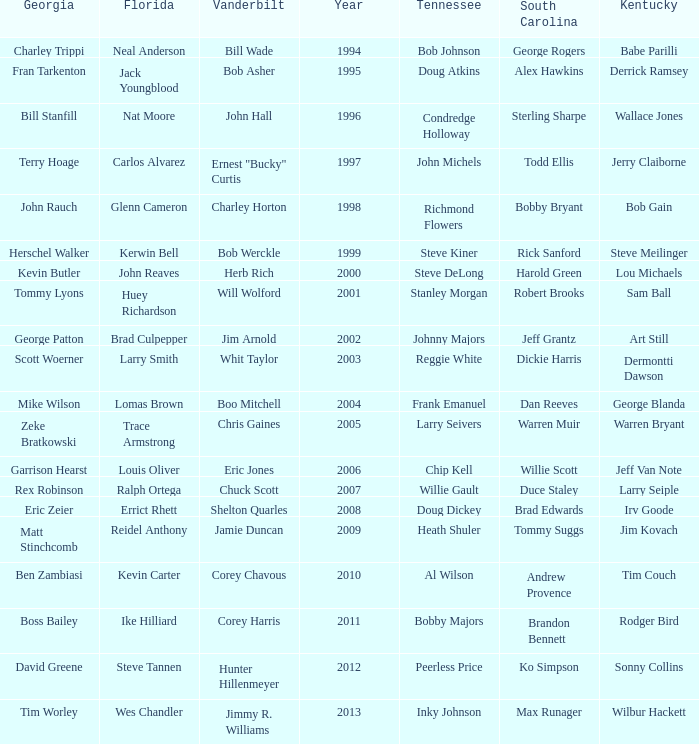What is the Tennessee with a Kentucky of Larry Seiple Willie Gault. Would you be able to parse every entry in this table? {'header': ['Georgia', 'Florida', 'Vanderbilt', 'Year', 'Tennessee', 'South Carolina', 'Kentucky'], 'rows': [['Charley Trippi', 'Neal Anderson', 'Bill Wade', '1994', 'Bob Johnson', 'George Rogers', 'Babe Parilli'], ['Fran Tarkenton', 'Jack Youngblood', 'Bob Asher', '1995', 'Doug Atkins', 'Alex Hawkins', 'Derrick Ramsey'], ['Bill Stanfill', 'Nat Moore', 'John Hall', '1996', 'Condredge Holloway', 'Sterling Sharpe', 'Wallace Jones'], ['Terry Hoage', 'Carlos Alvarez', 'Ernest "Bucky" Curtis', '1997', 'John Michels', 'Todd Ellis', 'Jerry Claiborne'], ['John Rauch', 'Glenn Cameron', 'Charley Horton', '1998', 'Richmond Flowers', 'Bobby Bryant', 'Bob Gain'], ['Herschel Walker', 'Kerwin Bell', 'Bob Werckle', '1999', 'Steve Kiner', 'Rick Sanford', 'Steve Meilinger'], ['Kevin Butler', 'John Reaves', 'Herb Rich', '2000', 'Steve DeLong', 'Harold Green', 'Lou Michaels'], ['Tommy Lyons', 'Huey Richardson', 'Will Wolford', '2001', 'Stanley Morgan', 'Robert Brooks', 'Sam Ball'], ['George Patton', 'Brad Culpepper', 'Jim Arnold', '2002', 'Johnny Majors', 'Jeff Grantz', 'Art Still'], ['Scott Woerner', 'Larry Smith', 'Whit Taylor', '2003', 'Reggie White', 'Dickie Harris', 'Dermontti Dawson'], ['Mike Wilson', 'Lomas Brown', 'Boo Mitchell', '2004', 'Frank Emanuel', 'Dan Reeves', 'George Blanda'], ['Zeke Bratkowski', 'Trace Armstrong', 'Chris Gaines', '2005', 'Larry Seivers', 'Warren Muir', 'Warren Bryant'], ['Garrison Hearst', 'Louis Oliver', 'Eric Jones', '2006', 'Chip Kell', 'Willie Scott', 'Jeff Van Note'], ['Rex Robinson', 'Ralph Ortega', 'Chuck Scott', '2007', 'Willie Gault', 'Duce Staley', 'Larry Seiple'], ['Eric Zeier', 'Errict Rhett', 'Shelton Quarles', '2008', 'Doug Dickey', 'Brad Edwards', 'Irv Goode'], ['Matt Stinchcomb', 'Reidel Anthony', 'Jamie Duncan', '2009', 'Heath Shuler', 'Tommy Suggs', 'Jim Kovach'], ['Ben Zambiasi', 'Kevin Carter', 'Corey Chavous', '2010', 'Al Wilson', 'Andrew Provence', 'Tim Couch'], ['Boss Bailey', 'Ike Hilliard', 'Corey Harris', '2011', 'Bobby Majors', 'Brandon Bennett', 'Rodger Bird'], ['David Greene', 'Steve Tannen', 'Hunter Hillenmeyer', '2012', 'Peerless Price', 'Ko Simpson', 'Sonny Collins'], ['Tim Worley', 'Wes Chandler', 'Jimmy R. Williams', '2013', 'Inky Johnson', 'Max Runager', 'Wilbur Hackett']]} 